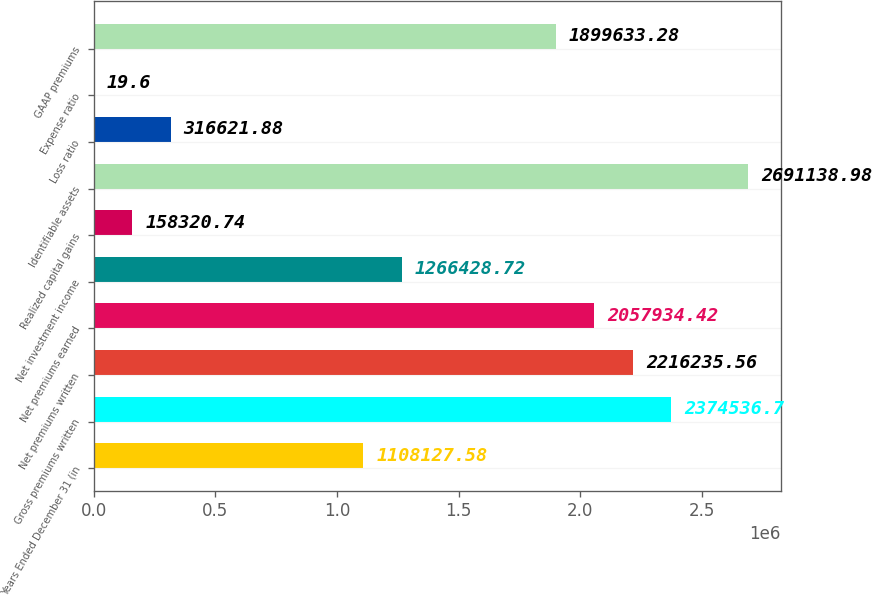<chart> <loc_0><loc_0><loc_500><loc_500><bar_chart><fcel>Years Ended December 31 (in<fcel>Gross premiums written<fcel>Net premiums written<fcel>Net premiums earned<fcel>Net investment income<fcel>Realized capital gains<fcel>Identifiable assets<fcel>Loss ratio<fcel>Expense ratio<fcel>GAAP premiums<nl><fcel>1.10813e+06<fcel>2.37454e+06<fcel>2.21624e+06<fcel>2.05793e+06<fcel>1.26643e+06<fcel>158321<fcel>2.69114e+06<fcel>316622<fcel>19.6<fcel>1.89963e+06<nl></chart> 